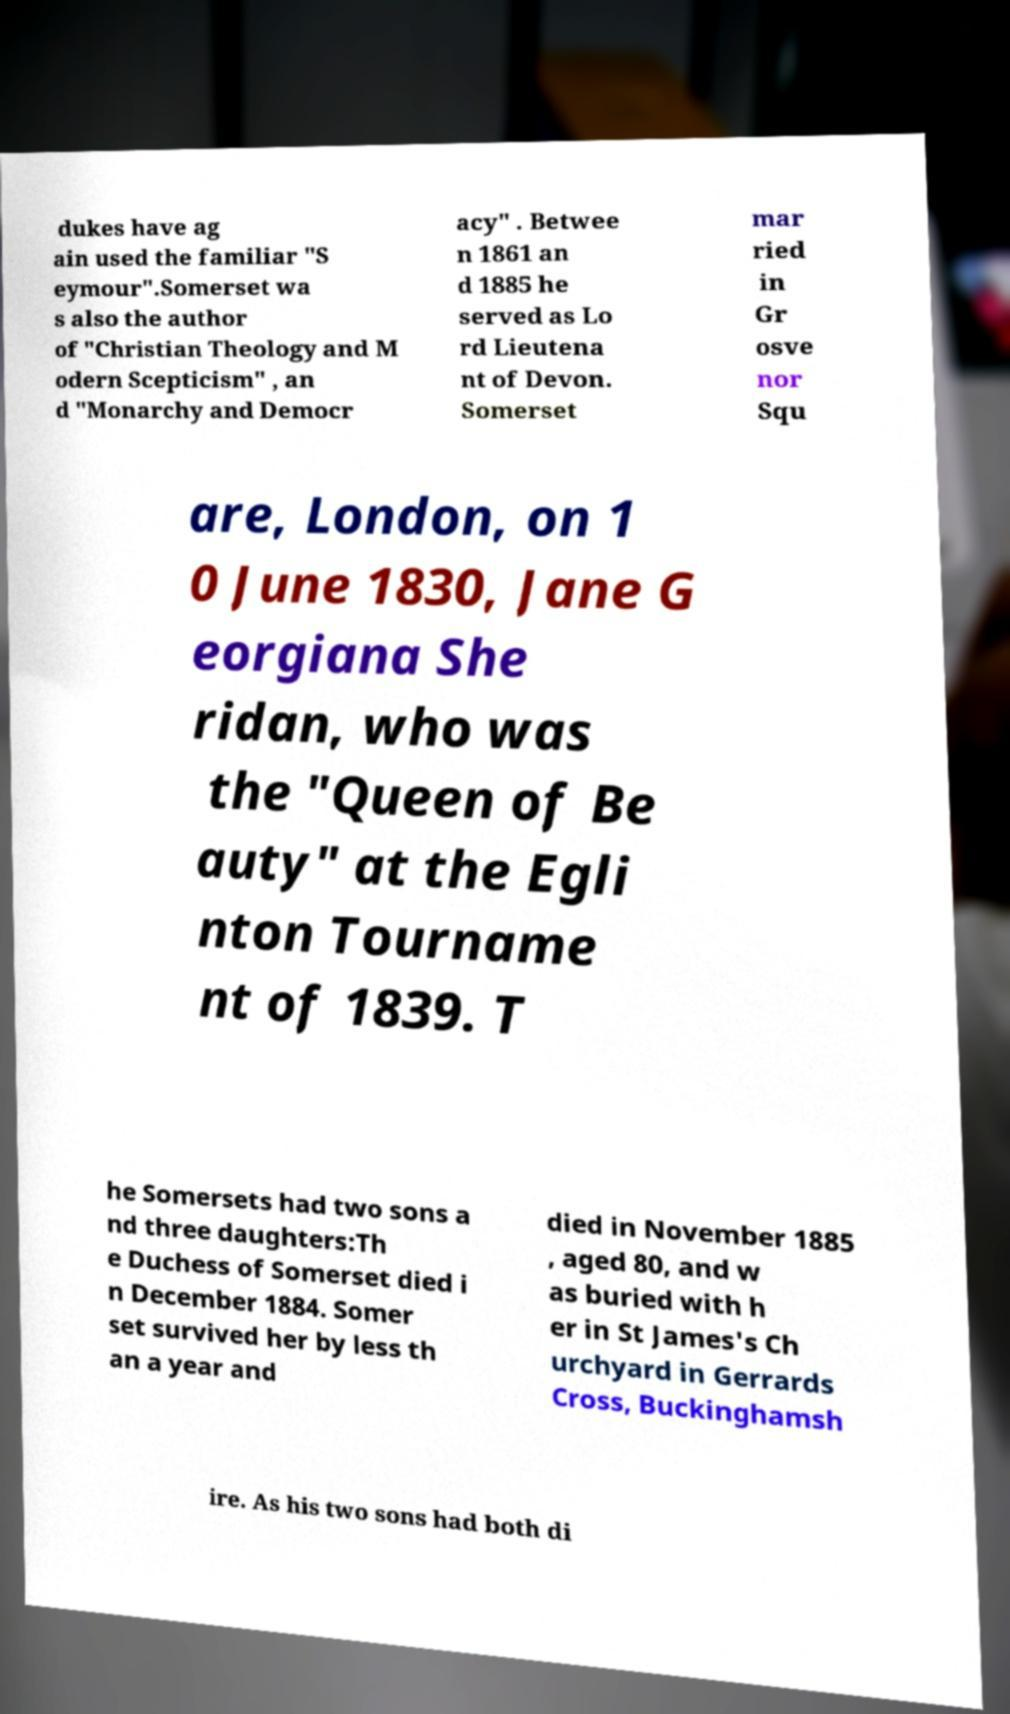Can you accurately transcribe the text from the provided image for me? dukes have ag ain used the familiar "S eymour".Somerset wa s also the author of "Christian Theology and M odern Scepticism" , an d "Monarchy and Democr acy" . Betwee n 1861 an d 1885 he served as Lo rd Lieutena nt of Devon. Somerset mar ried in Gr osve nor Squ are, London, on 1 0 June 1830, Jane G eorgiana She ridan, who was the "Queen of Be auty" at the Egli nton Tourname nt of 1839. T he Somersets had two sons a nd three daughters:Th e Duchess of Somerset died i n December 1884. Somer set survived her by less th an a year and died in November 1885 , aged 80, and w as buried with h er in St James's Ch urchyard in Gerrards Cross, Buckinghamsh ire. As his two sons had both di 